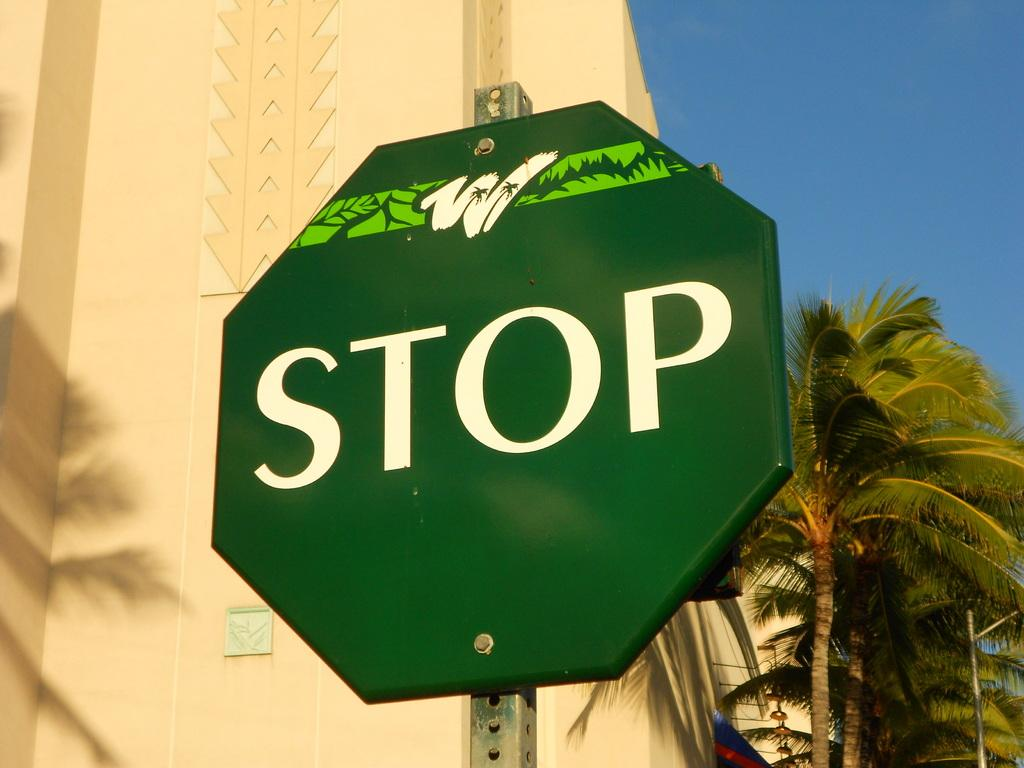<image>
Offer a succinct explanation of the picture presented. A green STOP sign sits in the foreground with palm trees behind it. 